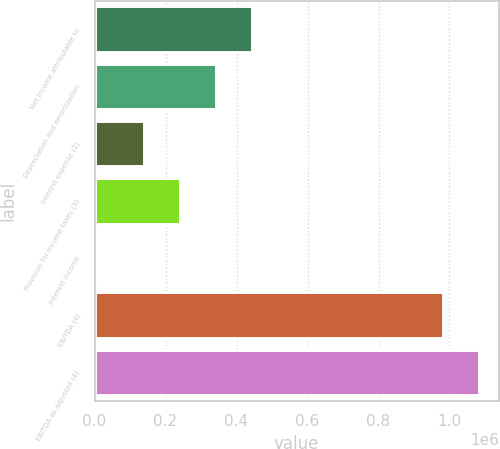<chart> <loc_0><loc_0><loc_500><loc_500><bar_chart><fcel>Net income attributable to<fcel>Depreciation and amortization<fcel>Interest expense (2)<fcel>Provision for income taxes (3)<fcel>Interest income<fcel>EBITDA (4)<fcel>EBITDA as adjusted (4)<nl><fcel>443169<fcel>341572<fcel>138379<fcel>239976<fcel>6289<fcel>982883<fcel>1.08448e+06<nl></chart> 